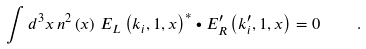Convert formula to latex. <formula><loc_0><loc_0><loc_500><loc_500>\int d ^ { 3 } x \, n ^ { 2 } \left ( { x } \right ) \, { E } _ { L } \left ( k _ { i } , 1 , { x } \right ) ^ { * } \bullet { E } _ { R } ^ { \prime } \left ( k ^ { \prime } _ { i } , 1 , { x } \right ) = 0 \quad .</formula> 